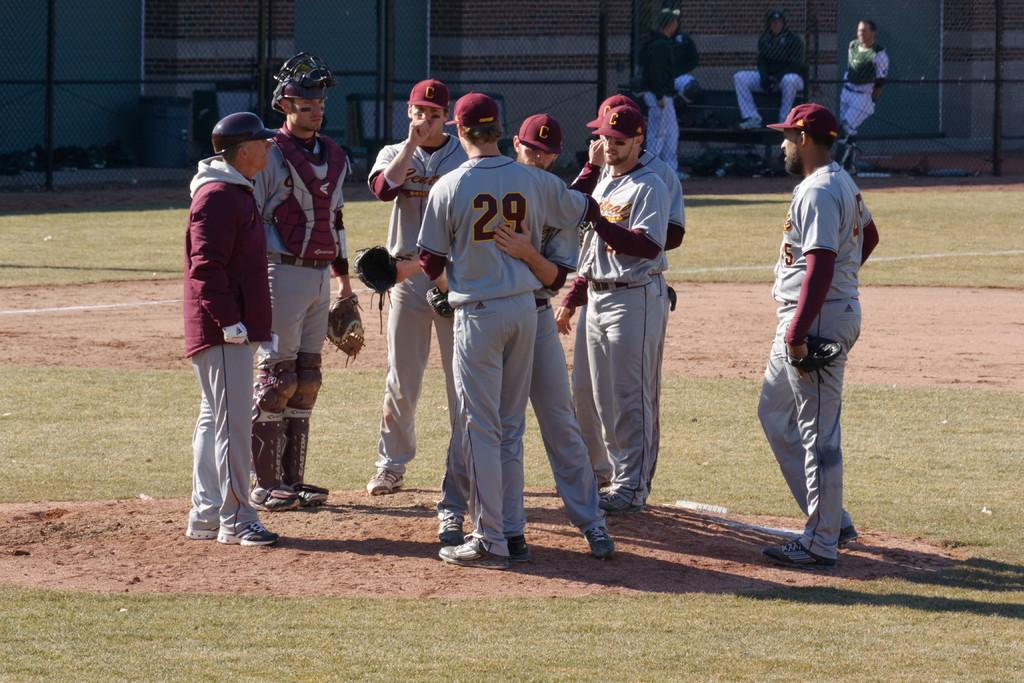<image>
Describe the image concisely. A group of basball players standing near the pitcher's mound and one player embracing player number 29. 